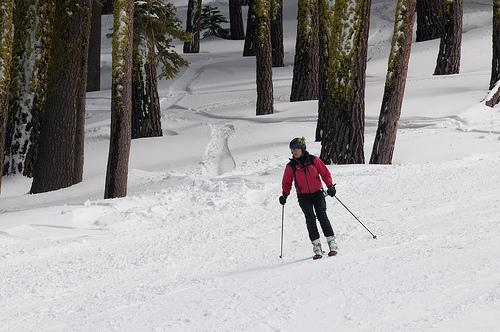Question: what is on the trees?
Choices:
A. Leaves.
B. Moss.
C. Snow.
D. Bark.
Answer with the letter. Answer: B Question: what is on the ground?
Choices:
A. Water.
B. Grass.
C. Snow.
D. Leaves.
Answer with the letter. Answer: C Question: who is skiing?
Choices:
A. The woman.
B. The man.
C. The children.
D. The family.
Answer with the letter. Answer: A 